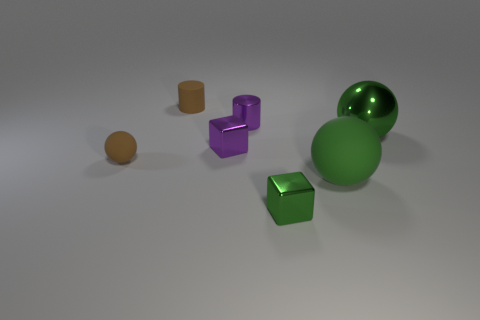Add 1 green metal balls. How many objects exist? 8 Subtract all balls. How many objects are left? 4 Add 5 purple shiny objects. How many purple shiny objects exist? 7 Subtract 0 blue blocks. How many objects are left? 7 Subtract all shiny things. Subtract all tiny brown matte cylinders. How many objects are left? 2 Add 7 large metallic objects. How many large metallic objects are left? 8 